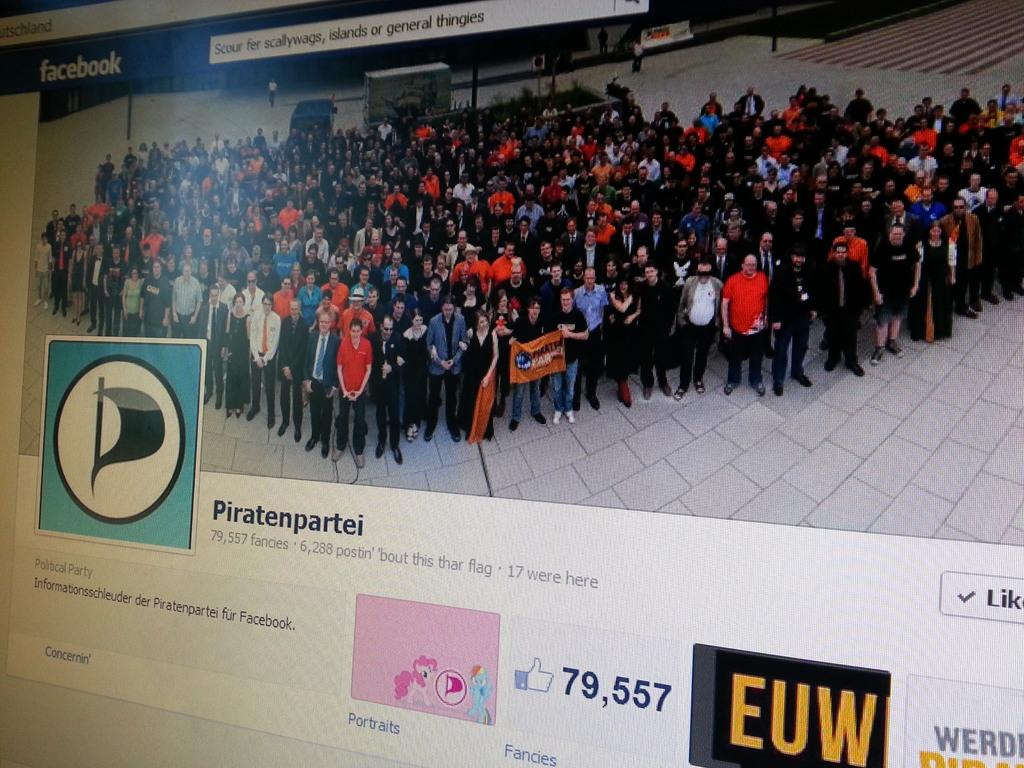<image>
Share a concise interpretation of the image provided. A Facebook page with 79,557 likes is displayed on the screen 